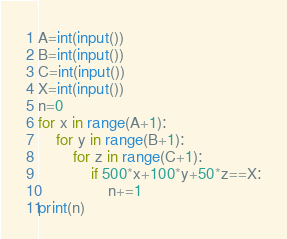<code> <loc_0><loc_0><loc_500><loc_500><_Python_>A=int(input())
B=int(input())
C=int(input())
X=int(input())
n=0
for x in range(A+1):
    for y in range(B+1):
        for z in range(C+1):
            if 500*x+100*y+50*z==X:
                n+=1
print(n)</code> 